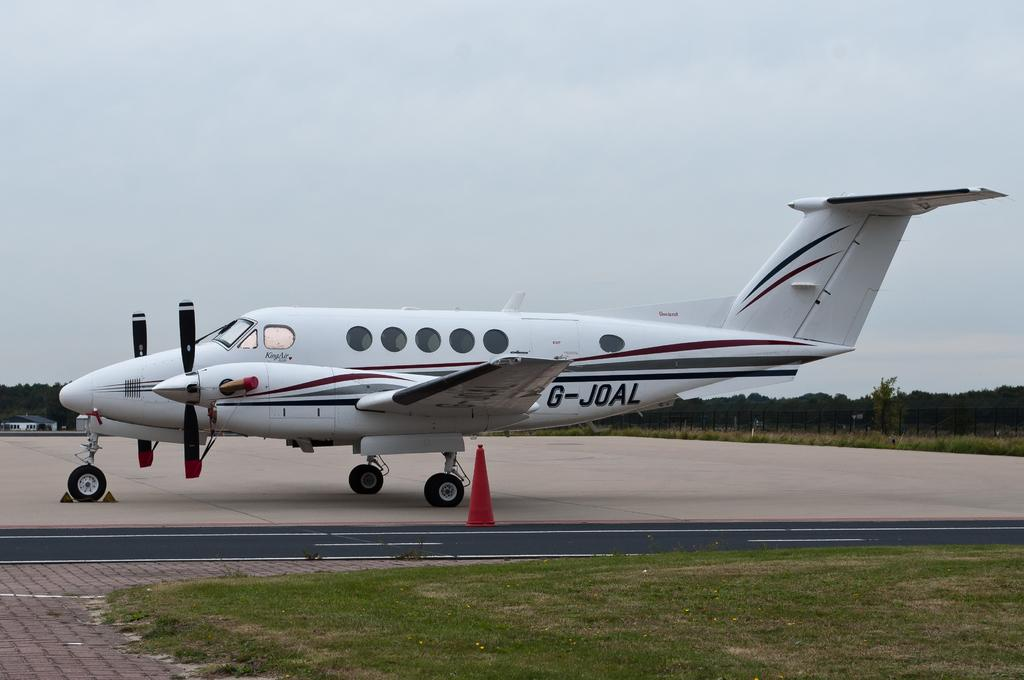<image>
Offer a succinct explanation of the picture presented. a small white with red and blue striped G-JOAL plane 